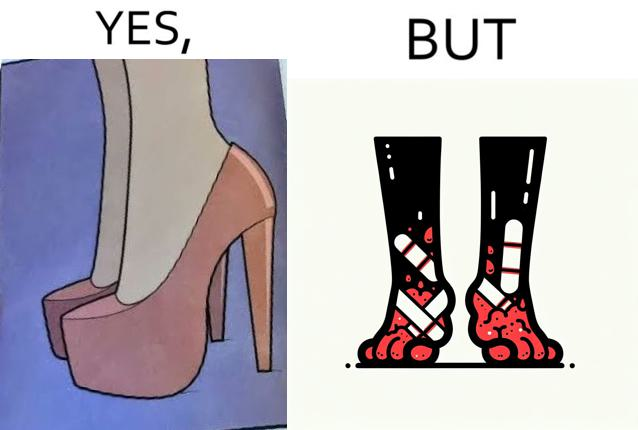What is shown in the left half versus the right half of this image? In the left part of the image: a pair of high heeled shoes In the right part of the image: A pair of feet, blistered and red, with bandages 